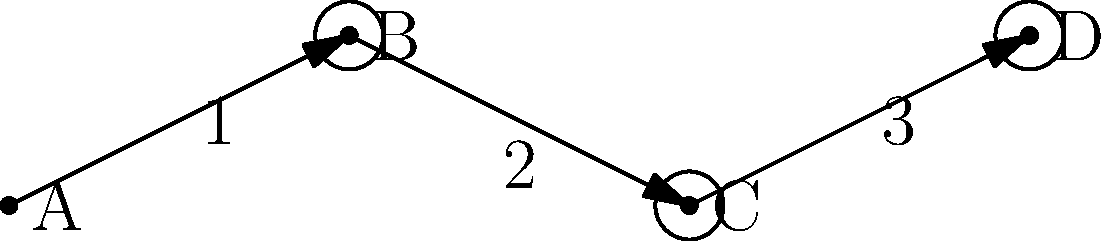In the simplified neural circuit diagram above, identify the correct sequence of neural signal transmission from neuron A to neuron D. Assume that each numbered arrow represents a step in the signal transmission process. To determine the correct sequence of neural signal transmission, we need to follow the path from neuron A to neuron D, considering the numbered steps:

1. The signal starts at neuron A and follows arrow 1 to reach the synapse of neuron B.
2. At the synapse of neuron B, the electrical signal is converted to a chemical signal, which crosses the synaptic cleft.
3. The chemical signal is received by neuron C, where it is converted back to an electrical signal. This process is represented by arrow 2.
4. The electrical signal travels along the axon of neuron C, following arrow 3 to reach the synapse of neuron D.

The entire process follows the path: A → B → C → D, with each arrow representing a step in the signal transmission.

In neuroscience, this sequence represents the basic principle of neural communication, where signals are passed from one neuron to another through synapses. The process involves both electrical transmission within neurons and chemical transmission between neurons at synapses.
Answer: 1 → 2 → 3 